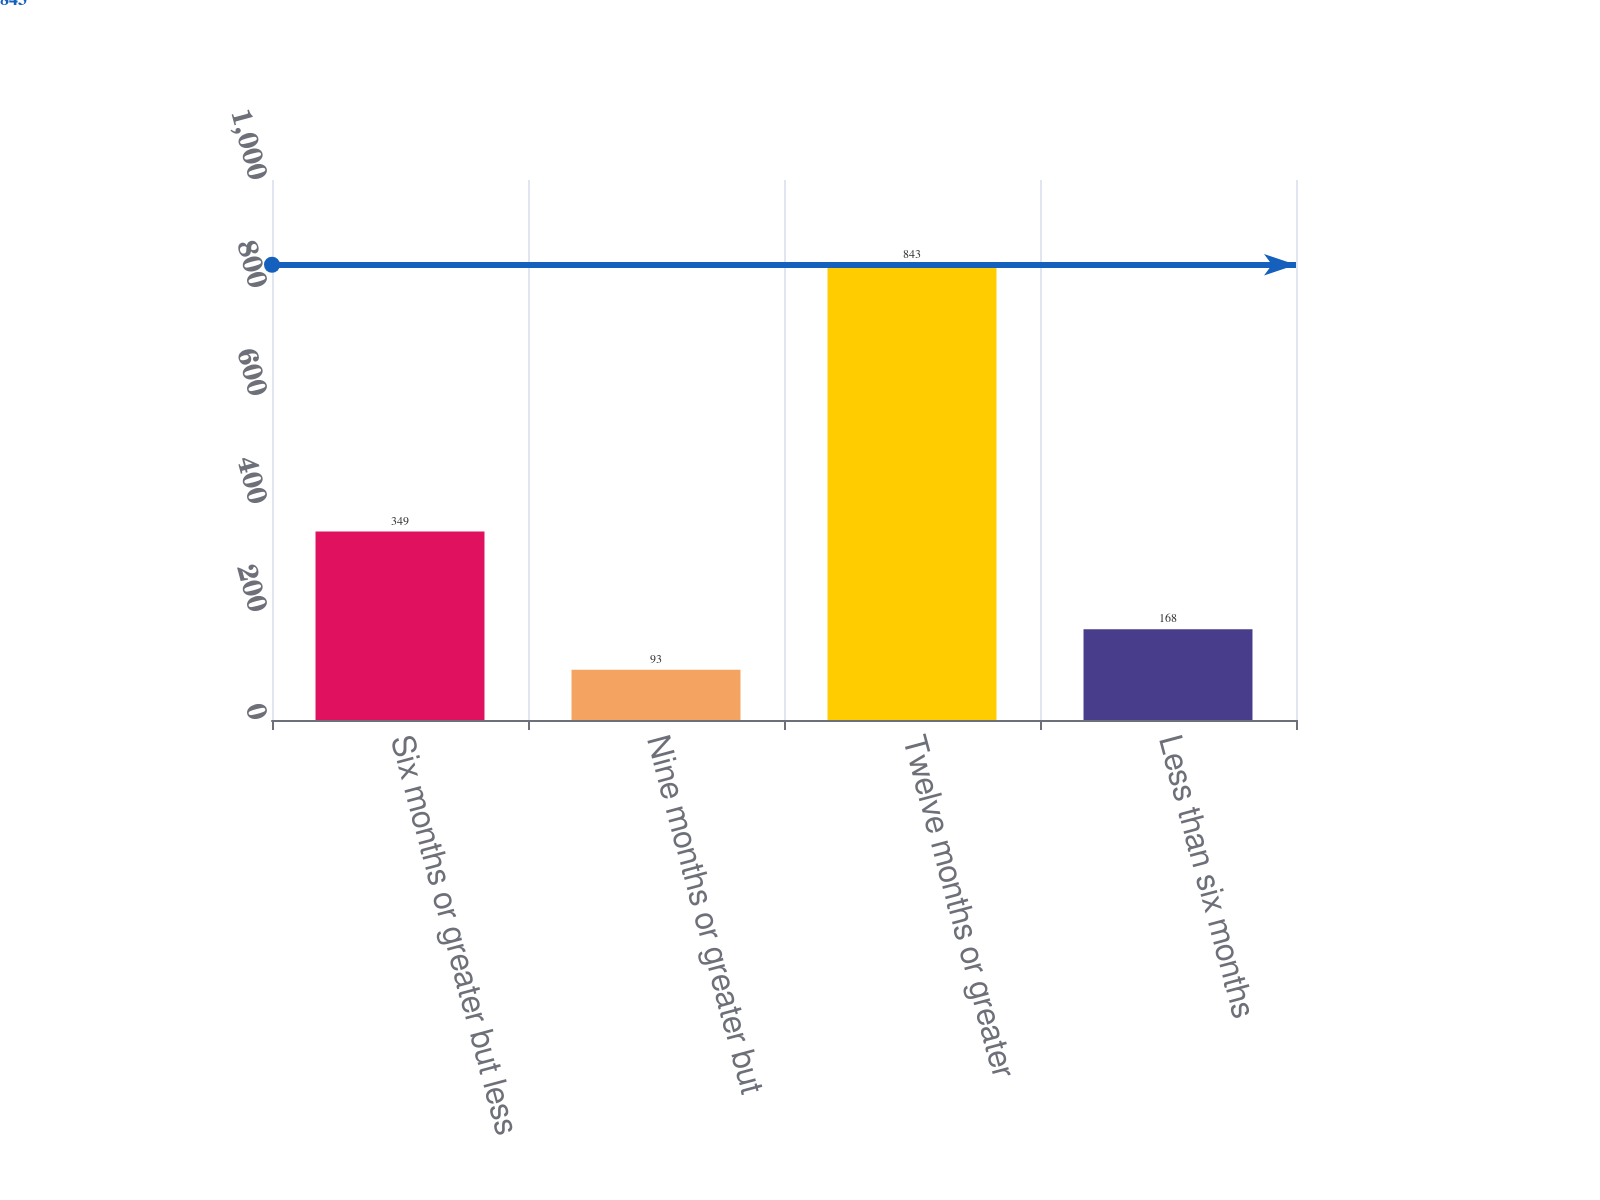Convert chart. <chart><loc_0><loc_0><loc_500><loc_500><bar_chart><fcel>Six months or greater but less<fcel>Nine months or greater but<fcel>Twelve months or greater<fcel>Less than six months<nl><fcel>349<fcel>93<fcel>843<fcel>168<nl></chart> 